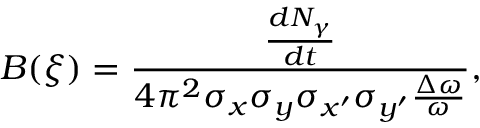<formula> <loc_0><loc_0><loc_500><loc_500>B ( \xi ) = \frac { \frac { d N _ { \gamma } } { d t } } { 4 \pi ^ { 2 } \sigma _ { x } \sigma _ { y } \sigma _ { x ^ { \prime } } \sigma _ { y ^ { \prime } } \frac { \Delta \omega } { \omega } } ,</formula> 